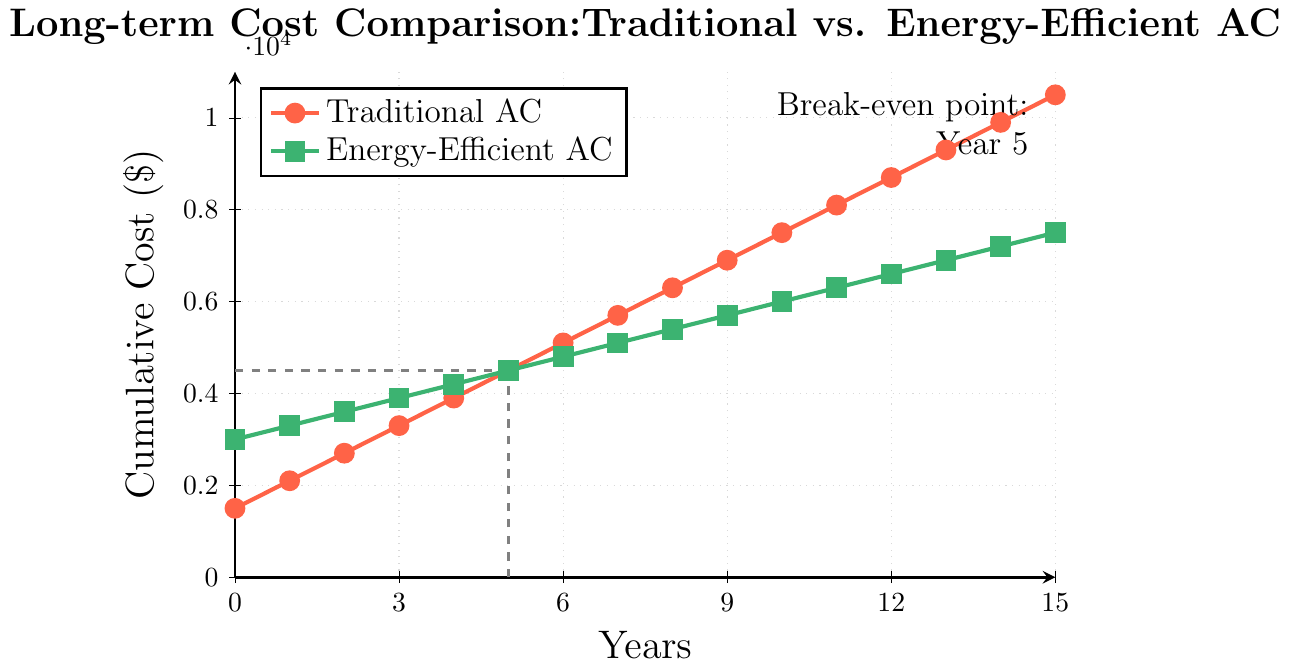What is the initial cost of the Traditional AC? The chart shows the initial cost at Year 0. For Traditional AC, the data point at Year 0 is $1500.
Answer: $1500 By how much is the initial cost of the Energy-Efficient AC higher than the Traditional AC? The initial cost of the Energy-Efficient AC is $3000 and the Traditional AC is $1500. The difference is calculated as $3000 - $1500.
Answer: $1500 How much does the Traditional AC cost after 10 years? The chart shows the cumulative cost of Traditional AC at Year 10. According to the plot, it is $7500.
Answer: $7500 At what year do the cumulative costs of both AC types become equal? The charts for both AC types intersect. This intersection point is labeled "Break-even point: Year 5".
Answer: Year 5 Which AC type has a lower cumulative cost after 15 years? After 15 years, the cumulative cost for Traditional AC is $10500, and for Energy-Efficient AC, it is $7500. Energy-Efficient AC has the lower cost.
Answer: Energy-Efficient AC What is the total cost difference between Traditional and Energy-Efficient ACs after 15 years? After 15 years, the cost for Traditional AC is $10500 and for Energy-Efficient AC is $7500. The difference is $10500 - $7500.
Answer: $3000 From Year 3 to Year 7, how much does the cumulative cost of the Traditional AC increase? The cost at Year 3 is $3300 and at Year 7 is $5700. The increase is $5700 - $3300.
Answer: $2400 What is the color used to represent the Energy-Efficient AC in the chart? The chart uses visual elements to distinguish data points. The Energy-Efficient AC is represented in green.
Answer: Green How much does the Energy-Efficient AC cost by year 6? The chart shows the cumulative costs. For Energy-Efficient AC, the cost at Year 6 is $4800.
Answer: $4800 How much less does the Energy-Efficient AC cost than the Traditional AC in Year 12? At Year 12, the cost of Traditional AC is $8700, and Energy-Efficient AC is $6600. The difference is $8700 - $6600.
Answer: $2100 